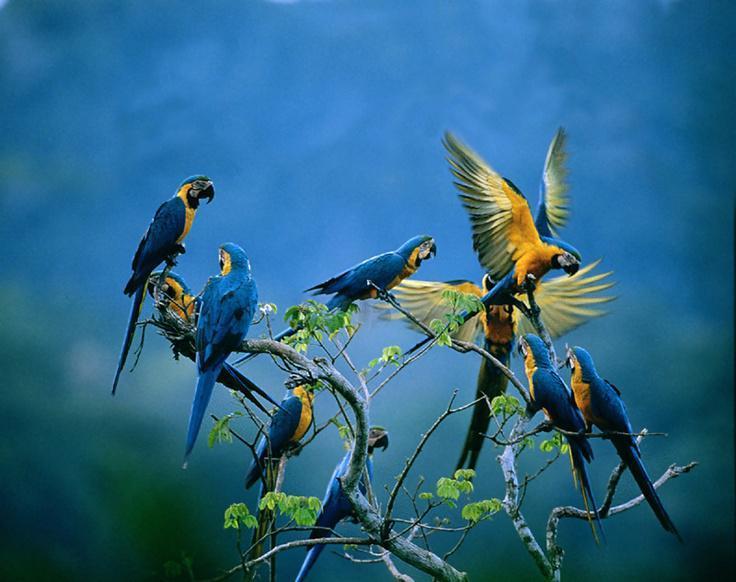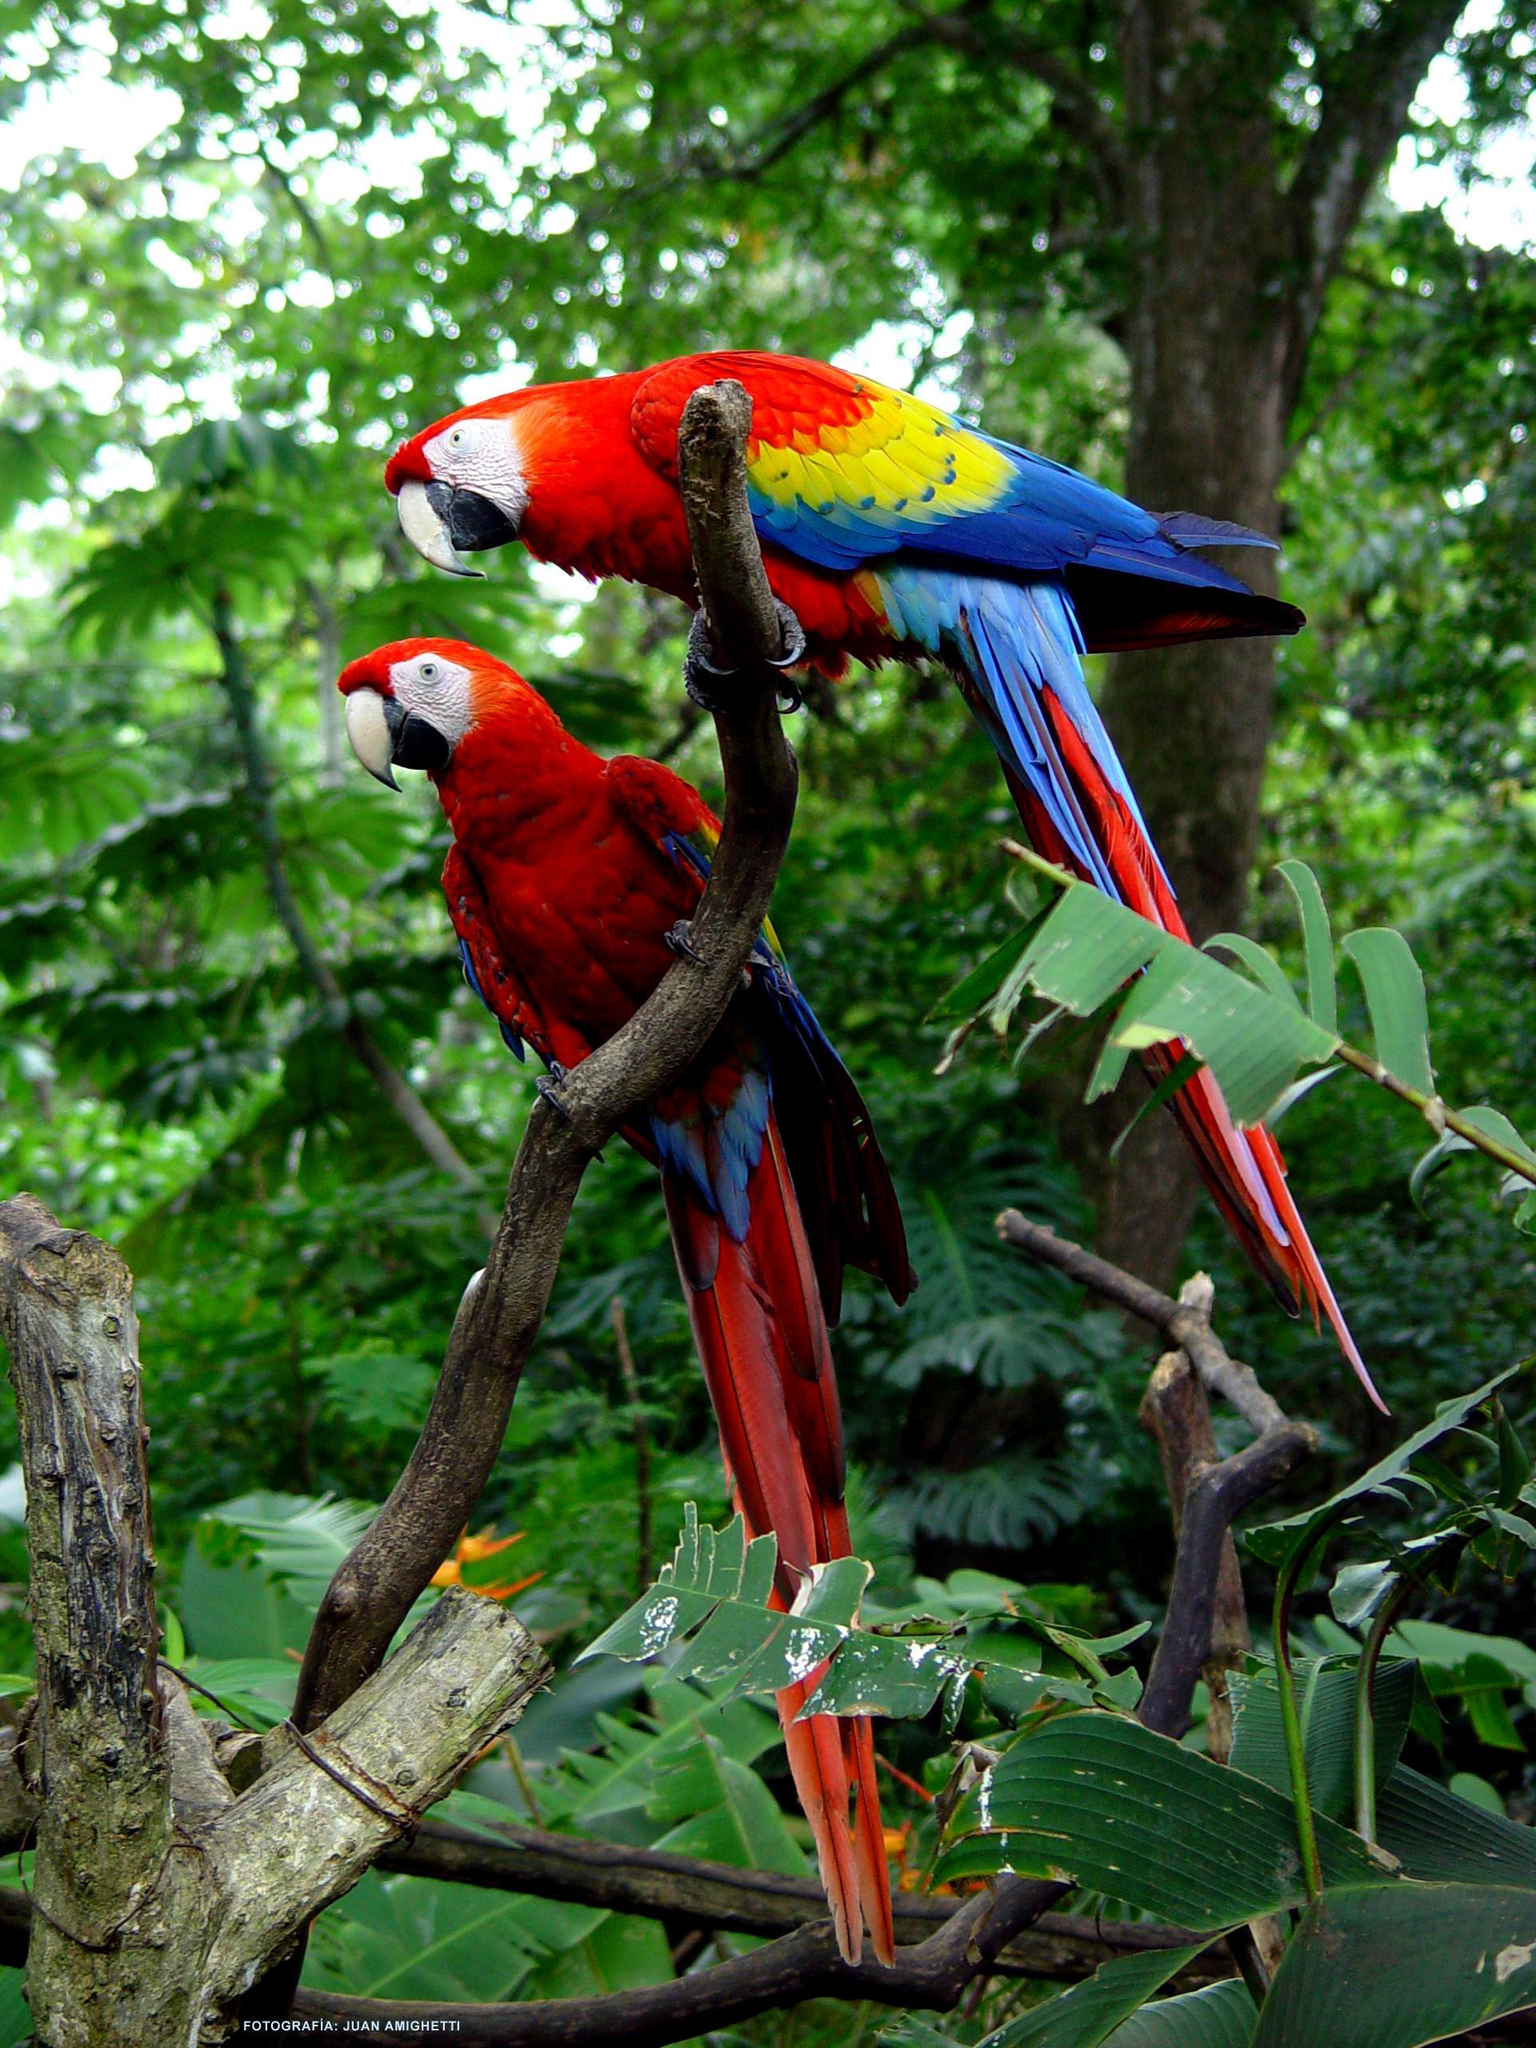The first image is the image on the left, the second image is the image on the right. Given the left and right images, does the statement "There are exactly two birds in the image on the right." hold true? Answer yes or no. Yes. 